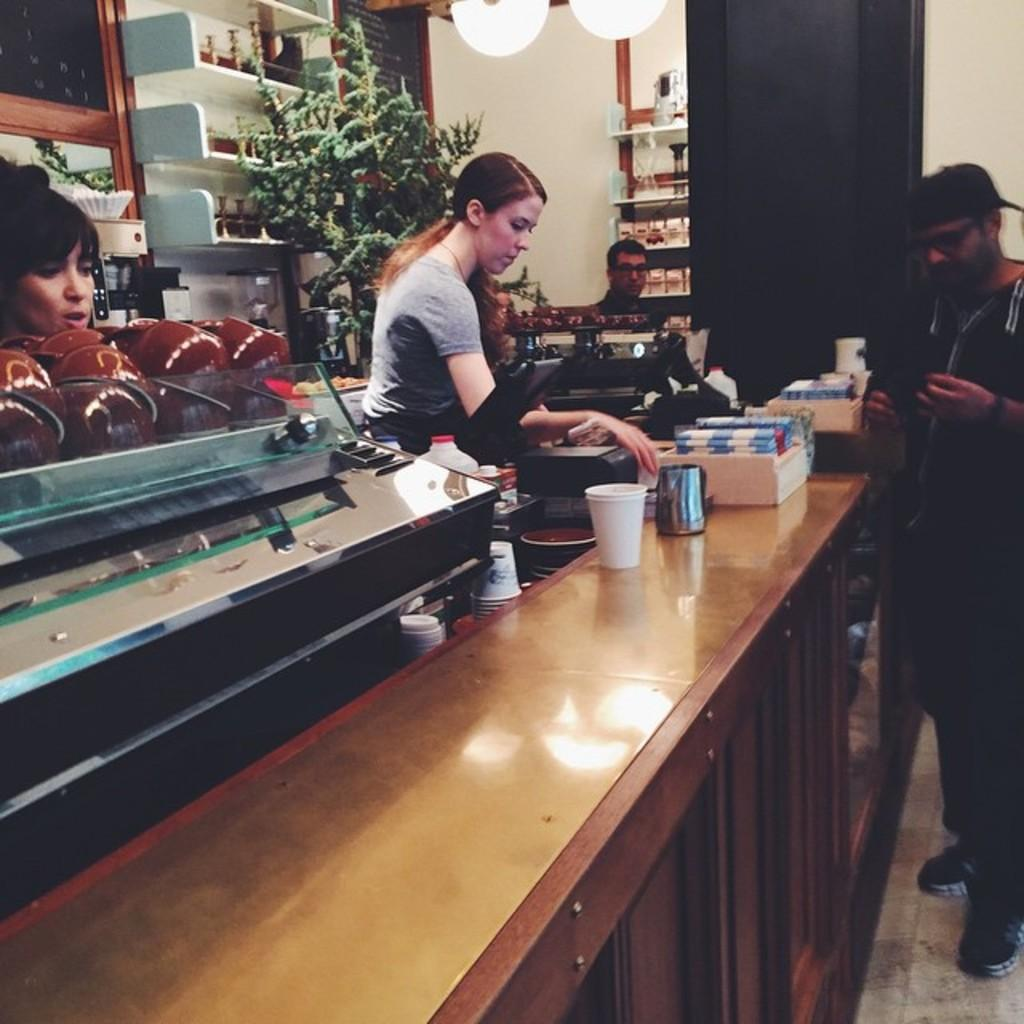How many people are present in the image? There are four persons standing in the image. What can be seen on the table in the image? There is a cup on the table in the image, and there are objects placed on the table as well. Can you describe the object at the back side of the image? There is a flower pot at the back side of the image. What type of authority figure is present in the image? There is no authority figure present in the image; it features four persons standing and a table with objects. 